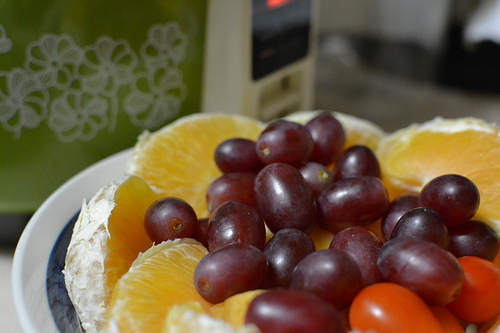<image>
Is there a fruits on the plate? Yes. Looking at the image, I can see the fruits is positioned on top of the plate, with the plate providing support. Is the grape in front of the orange? Yes. The grape is positioned in front of the orange, appearing closer to the camera viewpoint. 